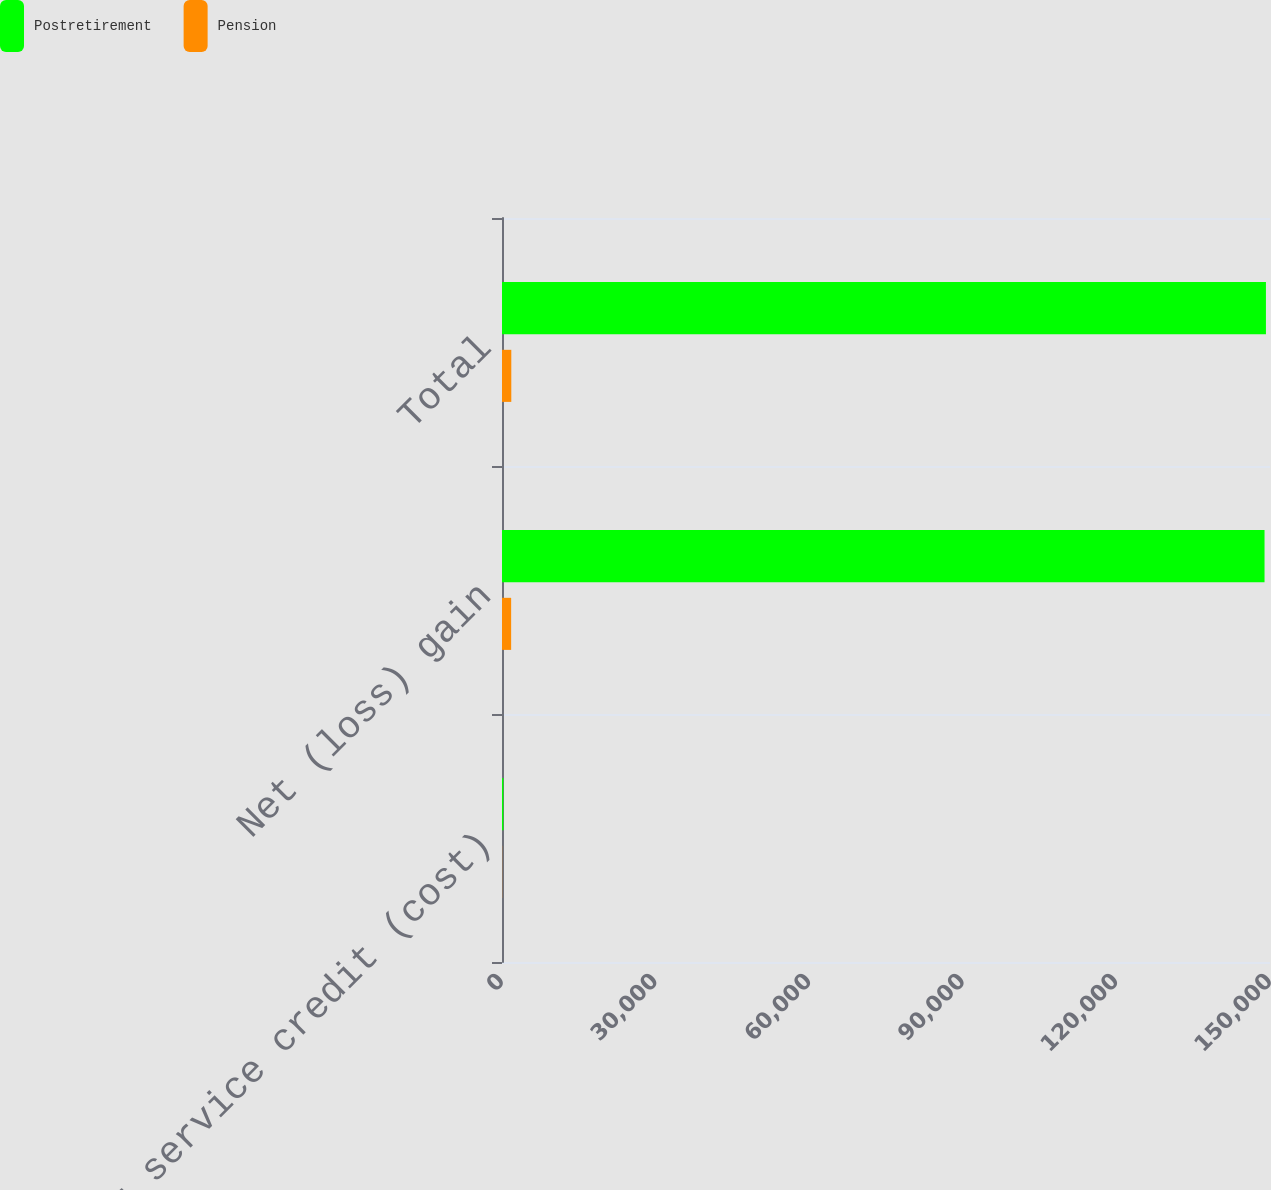<chart> <loc_0><loc_0><loc_500><loc_500><stacked_bar_chart><ecel><fcel>Prior service credit (cost)<fcel>Net (loss) gain<fcel>Total<nl><fcel>Postretirement<fcel>275<fcel>148933<fcel>149208<nl><fcel>Pension<fcel>30<fcel>1786<fcel>1816<nl></chart> 